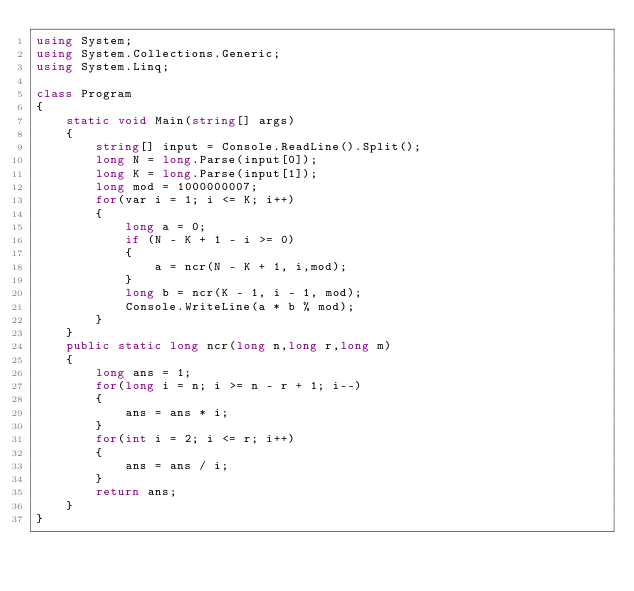Convert code to text. <code><loc_0><loc_0><loc_500><loc_500><_C#_>using System;
using System.Collections.Generic;
using System.Linq;

class Program
{
    static void Main(string[] args)
    {
        string[] input = Console.ReadLine().Split();
        long N = long.Parse(input[0]);
        long K = long.Parse(input[1]);
        long mod = 1000000007;
        for(var i = 1; i <= K; i++)
        {
            long a = 0;
            if (N - K + 1 - i >= 0)
            {
                a = ncr(N - K + 1, i,mod);
            }
            long b = ncr(K - 1, i - 1, mod);
            Console.WriteLine(a * b % mod);
        }
    }
    public static long ncr(long n,long r,long m)
    {
        long ans = 1;
        for(long i = n; i >= n - r + 1; i--)
        {
            ans = ans * i;
        }
        for(int i = 2; i <= r; i++)
        {
            ans = ans / i;
        }
        return ans;
    }
}
</code> 